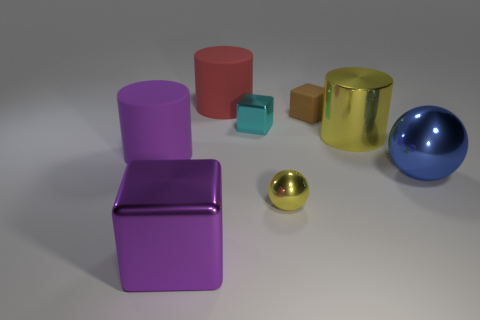Add 2 big green things. How many objects exist? 10 Subtract all cubes. How many objects are left? 5 Subtract all small yellow rubber cylinders. Subtract all brown matte objects. How many objects are left? 7 Add 5 cyan metallic things. How many cyan metallic things are left? 6 Add 1 gray matte blocks. How many gray matte blocks exist? 1 Subtract 0 brown spheres. How many objects are left? 8 